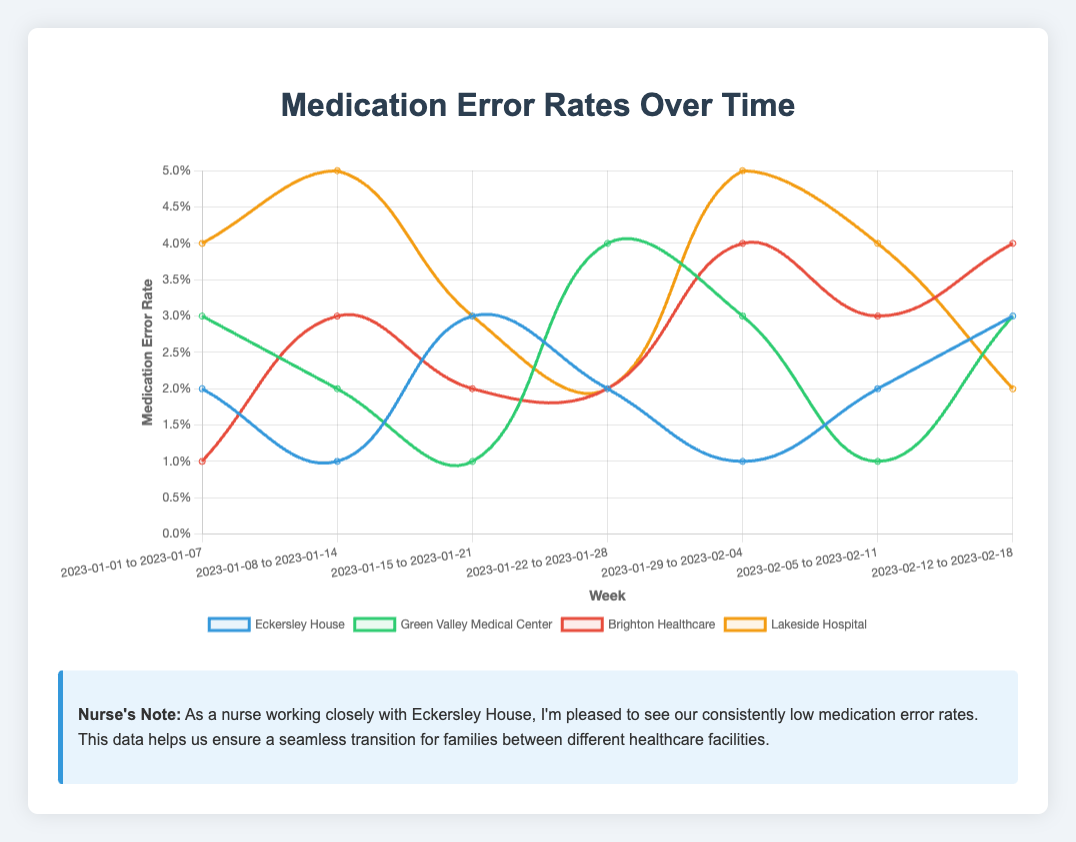What was the medication error rate at Eckersley House during the week of 2023-01-08 to 2023-01-14? Identify the "2023-01-08 to 2023-01-14" week on the x-axis. Find the corresponding point for Eckersley House, represented by the color in the legend. The value is 0.01.
Answer: 0.01 Which hospital had the highest medication error rate in the week of 2023-01-22 to 2023-01-28? Check the data points for each hospital during the week of "2023-01-22 to 2023-01-28". The highest rate is at Green Valley Medical Center with 0.04.
Answer: Green Valley Medical Center What is the average medication error rate for Eckersley House over the seven weeks? Add the weekly rates (0.02 + 0.01 + 0.03 + 0.02 + 0.01 + 0.02 + 0.03) and divide by 7. (0.14/7) = 0.02
Answer: 0.02 During which week did Brighton Healthcare experience its highest medication error rate? Identify Brighton Healthcare's color in the legend, then compare its data points across all weeks. The highest error rate (0.04) occurs during the week of "2023-01-29 to 2023-02-04."
Answer: 2023-01-29 to 2023-02-04 How does Eckersley House's error rate compare to Lakeside Hospital's for the week of 2023-01-15 to 2023-01-21? For the week "2023-01-15 to 2023-01-21," Eckersley House has an error rate of 0.03 while Lakeside Hospital has an error rate of 0.03. Both rates are equal.
Answer: They are equal Which week saw the highest overall medication error rate across all hospitals? Sum the error rates for all hospitals for each week, then find the week with the highest total error rate. The max sum is for "2023-01-29 to 2023-02-04" (0.01 + 0.03 + 0.04 + 0.05 = 0.13).
Answer: 2023-01-29 to 2023-02-04 Which hospital shows the most fluctuation in medication error rates over the given period? Examine the data trends for each hospital. Lakeside Hospital's error rates fluctuate the most, ranging from 0.02 to 0.05 with noticeable movements each week.
Answer: Lakeside Hospital What was the trend in Eckersley House medication error rates from week 2023-01-01 to 2023-01-07 to week 2023-01-08 to 2023-01-14? Identify the weeks "2023-01-01 to 2023-01-07" and "2023-01-08 to 2023-01-14." Eckersley House's error rate decreased from 0.02 to 0.01, showing a downward trend.
Answer: Downward Which hospital had a consistently low error rate around 0.02 or below? Review each hospital's weekly rates. Brighton Healthcare consistently has rates around or below 0.02 except for the week of "2023-01-29 to 2023-02-04" (0.04).
Answer: Brighton Healthcare 